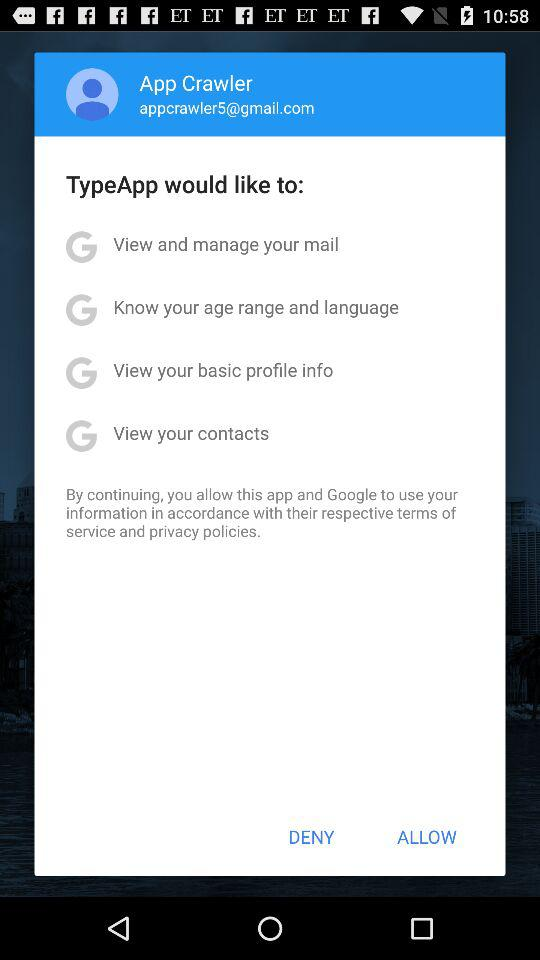What is the name of the user? The name of the user is App Crawler. 